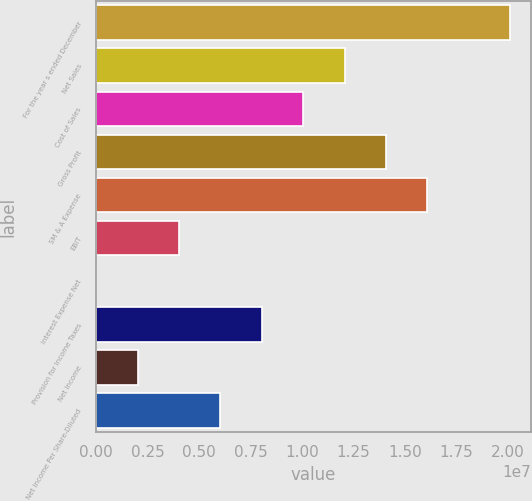Convert chart. <chart><loc_0><loc_0><loc_500><loc_500><bar_chart><fcel>For the year s ended December<fcel>Net Sales<fcel>Cost of Sales<fcel>Gross Profit<fcel>SM & A Expense<fcel>EBIT<fcel>Interest Expense Net<fcel>Provision for Income Taxes<fcel>Net Income<fcel>Net Income Per Share-Diluted<nl><fcel>2.0122e+07<fcel>1.20732e+07<fcel>1.0061e+07<fcel>1.40854e+07<fcel>1.60976e+07<fcel>4.02441e+06<fcel>3.7<fcel>8.04881e+06<fcel>2.0122e+06<fcel>6.03661e+06<nl></chart> 